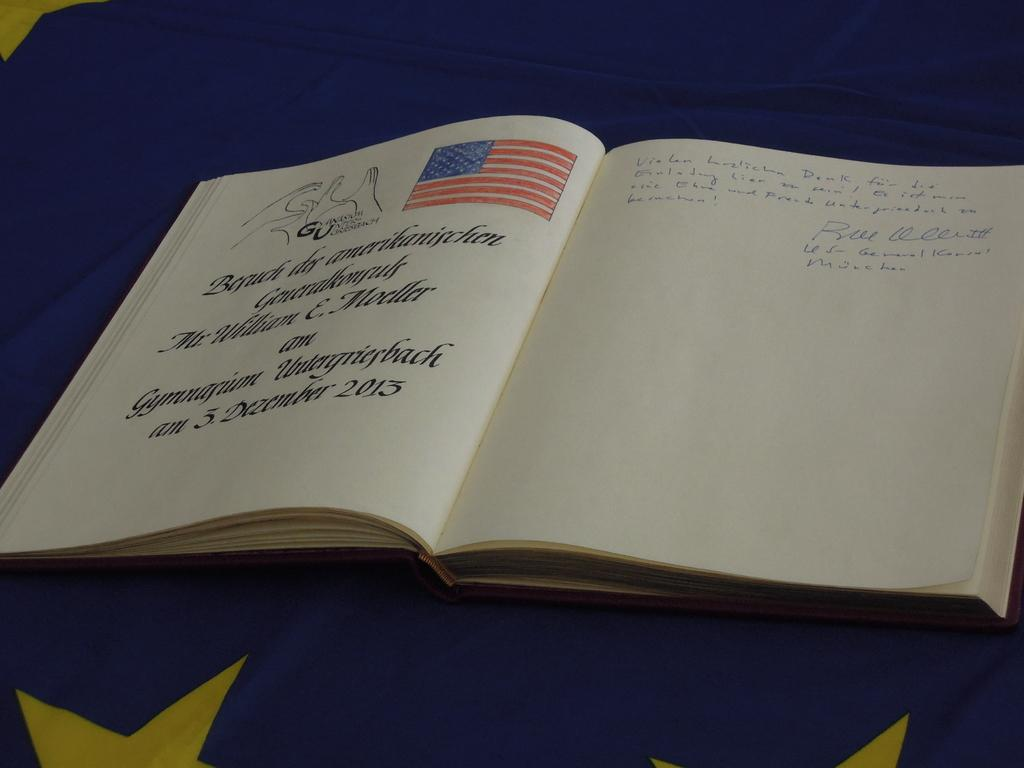<image>
Share a concise interpretation of the image provided. Mr. William E. Moeller was commemorated on December 3, 2013. 